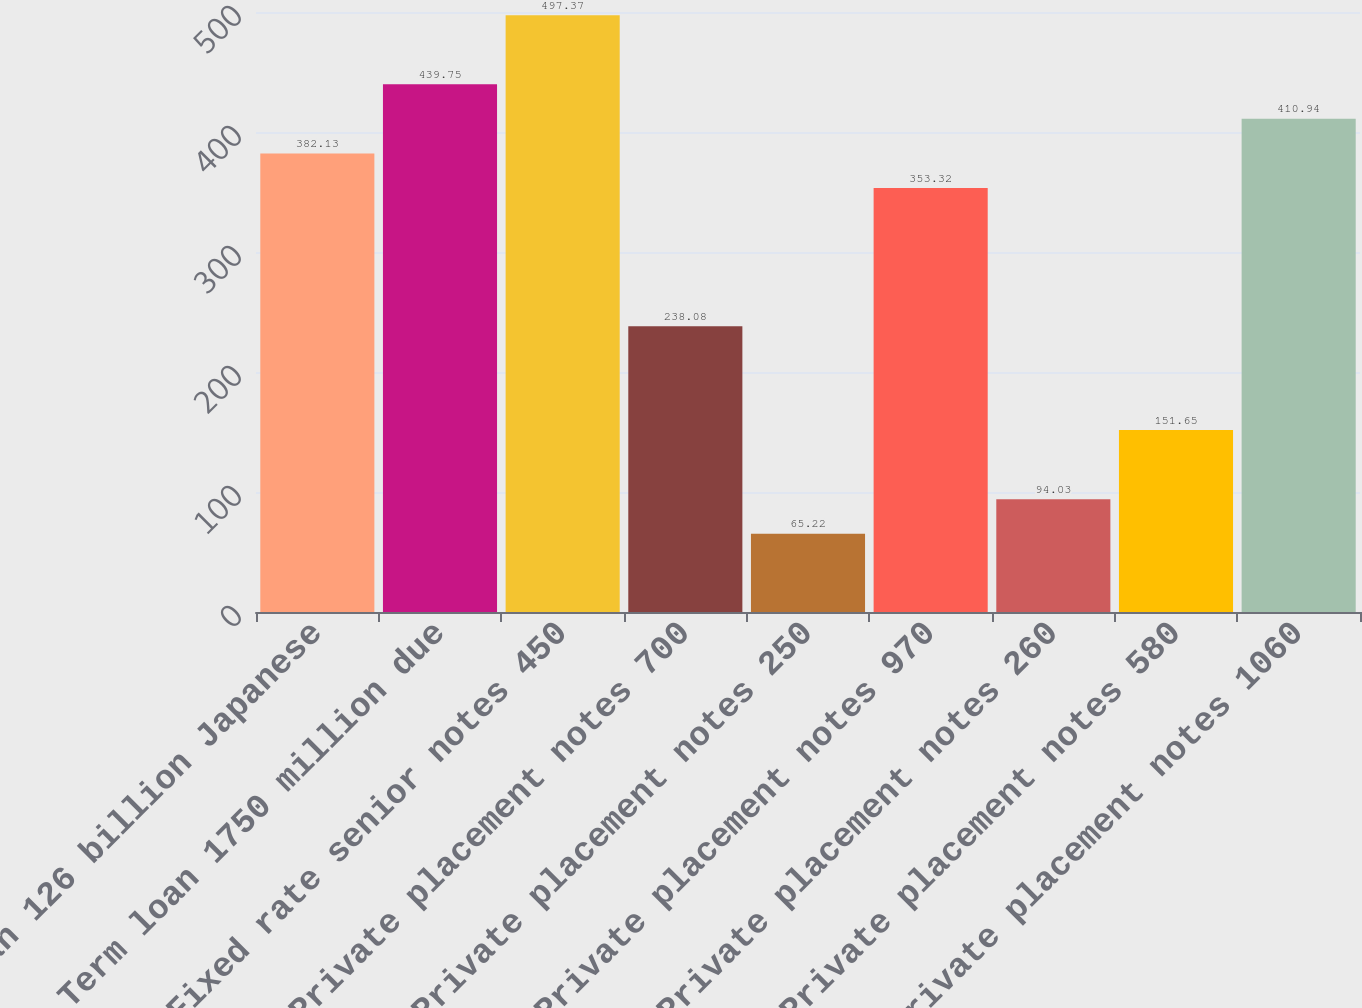<chart> <loc_0><loc_0><loc_500><loc_500><bar_chart><fcel>Term loan 126 billion Japanese<fcel>Term loan 1750 million due<fcel>Fixed rate senior notes 450<fcel>Private placement notes 700<fcel>Private placement notes 250<fcel>Private placement notes 970<fcel>Private placement notes 260<fcel>Private placement notes 580<fcel>Private placement notes 1060<nl><fcel>382.13<fcel>439.75<fcel>497.37<fcel>238.08<fcel>65.22<fcel>353.32<fcel>94.03<fcel>151.65<fcel>410.94<nl></chart> 